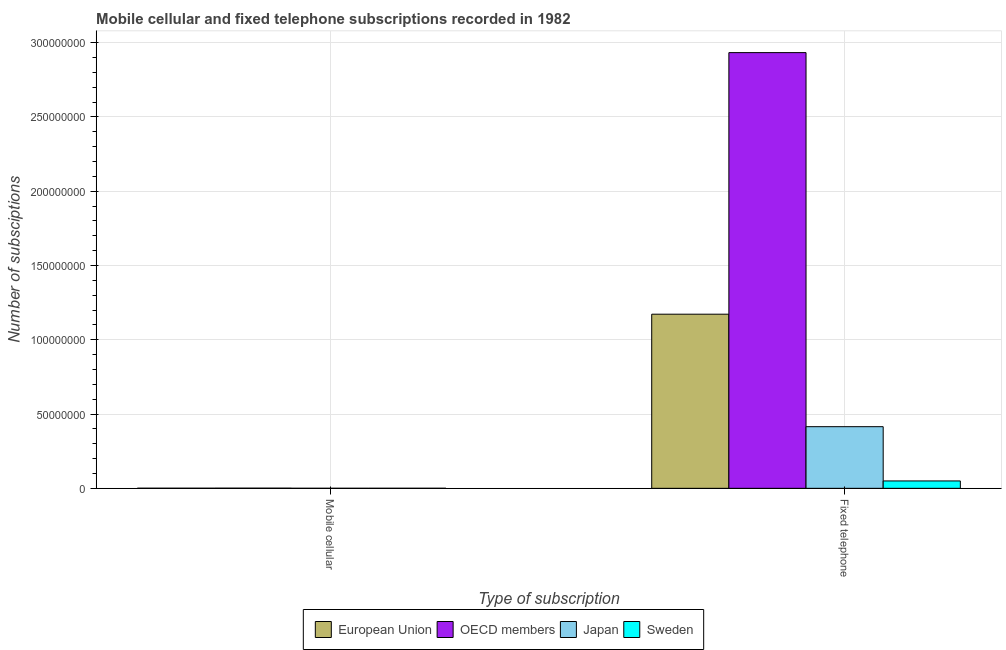Are the number of bars per tick equal to the number of legend labels?
Your answer should be compact. Yes. Are the number of bars on each tick of the X-axis equal?
Keep it short and to the point. Yes. How many bars are there on the 2nd tick from the left?
Ensure brevity in your answer.  4. How many bars are there on the 2nd tick from the right?
Offer a very short reply. 4. What is the label of the 2nd group of bars from the left?
Your response must be concise. Fixed telephone. What is the number of mobile cellular subscriptions in Sweden?
Provide a succinct answer. 2.72e+04. Across all countries, what is the maximum number of fixed telephone subscriptions?
Give a very brief answer. 2.93e+08. Across all countries, what is the minimum number of mobile cellular subscriptions?
Give a very brief answer. 1.98e+04. What is the total number of fixed telephone subscriptions in the graph?
Your response must be concise. 4.57e+08. What is the difference between the number of mobile cellular subscriptions in Japan and that in Sweden?
Your answer should be very brief. -7432. What is the difference between the number of mobile cellular subscriptions in Japan and the number of fixed telephone subscriptions in OECD members?
Ensure brevity in your answer.  -2.93e+08. What is the average number of mobile cellular subscriptions per country?
Offer a terse response. 5.36e+04. What is the difference between the number of fixed telephone subscriptions and number of mobile cellular subscriptions in OECD members?
Your answer should be very brief. 2.93e+08. What is the ratio of the number of mobile cellular subscriptions in Sweden to that in OECD members?
Offer a terse response. 0.27. In how many countries, is the number of mobile cellular subscriptions greater than the average number of mobile cellular subscriptions taken over all countries?
Offer a terse response. 2. What does the 1st bar from the left in Mobile cellular represents?
Offer a terse response. European Union. What does the 2nd bar from the right in Fixed telephone represents?
Provide a short and direct response. Japan. How many bars are there?
Ensure brevity in your answer.  8. Are all the bars in the graph horizontal?
Give a very brief answer. No. How many countries are there in the graph?
Your response must be concise. 4. What is the difference between two consecutive major ticks on the Y-axis?
Provide a succinct answer. 5.00e+07. Does the graph contain any zero values?
Your response must be concise. No. Does the graph contain grids?
Keep it short and to the point. Yes. How many legend labels are there?
Your answer should be very brief. 4. How are the legend labels stacked?
Your answer should be compact. Horizontal. What is the title of the graph?
Ensure brevity in your answer.  Mobile cellular and fixed telephone subscriptions recorded in 1982. What is the label or title of the X-axis?
Provide a short and direct response. Type of subscription. What is the label or title of the Y-axis?
Your answer should be very brief. Number of subsciptions. What is the Number of subsciptions in European Union in Mobile cellular?
Your answer should be very brief. 6.83e+04. What is the Number of subsciptions of OECD members in Mobile cellular?
Offer a terse response. 9.92e+04. What is the Number of subsciptions of Japan in Mobile cellular?
Offer a very short reply. 1.98e+04. What is the Number of subsciptions in Sweden in Mobile cellular?
Ensure brevity in your answer.  2.72e+04. What is the Number of subsciptions of European Union in Fixed telephone?
Keep it short and to the point. 1.17e+08. What is the Number of subsciptions of OECD members in Fixed telephone?
Provide a short and direct response. 2.93e+08. What is the Number of subsciptions of Japan in Fixed telephone?
Ensure brevity in your answer.  4.15e+07. What is the Number of subsciptions in Sweden in Fixed telephone?
Offer a terse response. 4.97e+06. Across all Type of subscription, what is the maximum Number of subsciptions of European Union?
Your answer should be very brief. 1.17e+08. Across all Type of subscription, what is the maximum Number of subsciptions of OECD members?
Provide a short and direct response. 2.93e+08. Across all Type of subscription, what is the maximum Number of subsciptions of Japan?
Provide a short and direct response. 4.15e+07. Across all Type of subscription, what is the maximum Number of subsciptions of Sweden?
Your answer should be very brief. 4.97e+06. Across all Type of subscription, what is the minimum Number of subsciptions in European Union?
Make the answer very short. 6.83e+04. Across all Type of subscription, what is the minimum Number of subsciptions in OECD members?
Your response must be concise. 9.92e+04. Across all Type of subscription, what is the minimum Number of subsciptions in Japan?
Offer a terse response. 1.98e+04. Across all Type of subscription, what is the minimum Number of subsciptions in Sweden?
Ensure brevity in your answer.  2.72e+04. What is the total Number of subsciptions in European Union in the graph?
Provide a succinct answer. 1.17e+08. What is the total Number of subsciptions in OECD members in the graph?
Your response must be concise. 2.93e+08. What is the total Number of subsciptions in Japan in the graph?
Offer a very short reply. 4.15e+07. What is the total Number of subsciptions of Sweden in the graph?
Your answer should be compact. 4.99e+06. What is the difference between the Number of subsciptions of European Union in Mobile cellular and that in Fixed telephone?
Provide a short and direct response. -1.17e+08. What is the difference between the Number of subsciptions in OECD members in Mobile cellular and that in Fixed telephone?
Provide a short and direct response. -2.93e+08. What is the difference between the Number of subsciptions in Japan in Mobile cellular and that in Fixed telephone?
Keep it short and to the point. -4.15e+07. What is the difference between the Number of subsciptions in Sweden in Mobile cellular and that in Fixed telephone?
Provide a succinct answer. -4.94e+06. What is the difference between the Number of subsciptions of European Union in Mobile cellular and the Number of subsciptions of OECD members in Fixed telephone?
Provide a short and direct response. -2.93e+08. What is the difference between the Number of subsciptions of European Union in Mobile cellular and the Number of subsciptions of Japan in Fixed telephone?
Your answer should be compact. -4.14e+07. What is the difference between the Number of subsciptions of European Union in Mobile cellular and the Number of subsciptions of Sweden in Fixed telephone?
Ensure brevity in your answer.  -4.90e+06. What is the difference between the Number of subsciptions of OECD members in Mobile cellular and the Number of subsciptions of Japan in Fixed telephone?
Your response must be concise. -4.14e+07. What is the difference between the Number of subsciptions in OECD members in Mobile cellular and the Number of subsciptions in Sweden in Fixed telephone?
Keep it short and to the point. -4.87e+06. What is the difference between the Number of subsciptions of Japan in Mobile cellular and the Number of subsciptions of Sweden in Fixed telephone?
Provide a succinct answer. -4.95e+06. What is the average Number of subsciptions of European Union per Type of subscription?
Provide a short and direct response. 5.86e+07. What is the average Number of subsciptions in OECD members per Type of subscription?
Your answer should be very brief. 1.47e+08. What is the average Number of subsciptions in Japan per Type of subscription?
Ensure brevity in your answer.  2.08e+07. What is the average Number of subsciptions of Sweden per Type of subscription?
Offer a very short reply. 2.50e+06. What is the difference between the Number of subsciptions of European Union and Number of subsciptions of OECD members in Mobile cellular?
Offer a very short reply. -3.09e+04. What is the difference between the Number of subsciptions in European Union and Number of subsciptions in Japan in Mobile cellular?
Provide a succinct answer. 4.85e+04. What is the difference between the Number of subsciptions of European Union and Number of subsciptions of Sweden in Mobile cellular?
Give a very brief answer. 4.11e+04. What is the difference between the Number of subsciptions of OECD members and Number of subsciptions of Japan in Mobile cellular?
Make the answer very short. 7.94e+04. What is the difference between the Number of subsciptions in OECD members and Number of subsciptions in Sweden in Mobile cellular?
Provide a short and direct response. 7.19e+04. What is the difference between the Number of subsciptions of Japan and Number of subsciptions of Sweden in Mobile cellular?
Make the answer very short. -7432. What is the difference between the Number of subsciptions of European Union and Number of subsciptions of OECD members in Fixed telephone?
Your answer should be very brief. -1.76e+08. What is the difference between the Number of subsciptions in European Union and Number of subsciptions in Japan in Fixed telephone?
Provide a short and direct response. 7.57e+07. What is the difference between the Number of subsciptions in European Union and Number of subsciptions in Sweden in Fixed telephone?
Your answer should be very brief. 1.12e+08. What is the difference between the Number of subsciptions in OECD members and Number of subsciptions in Japan in Fixed telephone?
Offer a terse response. 2.52e+08. What is the difference between the Number of subsciptions in OECD members and Number of subsciptions in Sweden in Fixed telephone?
Give a very brief answer. 2.88e+08. What is the difference between the Number of subsciptions of Japan and Number of subsciptions of Sweden in Fixed telephone?
Keep it short and to the point. 3.65e+07. What is the ratio of the Number of subsciptions of European Union in Mobile cellular to that in Fixed telephone?
Give a very brief answer. 0. What is the ratio of the Number of subsciptions of OECD members in Mobile cellular to that in Fixed telephone?
Provide a succinct answer. 0. What is the ratio of the Number of subsciptions in Japan in Mobile cellular to that in Fixed telephone?
Ensure brevity in your answer.  0. What is the ratio of the Number of subsciptions of Sweden in Mobile cellular to that in Fixed telephone?
Your response must be concise. 0.01. What is the difference between the highest and the second highest Number of subsciptions in European Union?
Your answer should be very brief. 1.17e+08. What is the difference between the highest and the second highest Number of subsciptions in OECD members?
Offer a very short reply. 2.93e+08. What is the difference between the highest and the second highest Number of subsciptions of Japan?
Keep it short and to the point. 4.15e+07. What is the difference between the highest and the second highest Number of subsciptions in Sweden?
Provide a succinct answer. 4.94e+06. What is the difference between the highest and the lowest Number of subsciptions of European Union?
Make the answer very short. 1.17e+08. What is the difference between the highest and the lowest Number of subsciptions in OECD members?
Provide a succinct answer. 2.93e+08. What is the difference between the highest and the lowest Number of subsciptions in Japan?
Ensure brevity in your answer.  4.15e+07. What is the difference between the highest and the lowest Number of subsciptions in Sweden?
Make the answer very short. 4.94e+06. 